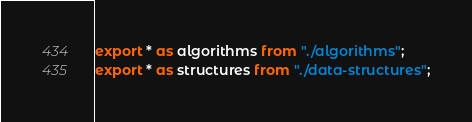Convert code to text. <code><loc_0><loc_0><loc_500><loc_500><_JavaScript_>export * as algorithms from "./algorithms";
export * as structures from "./data-structures";</code> 